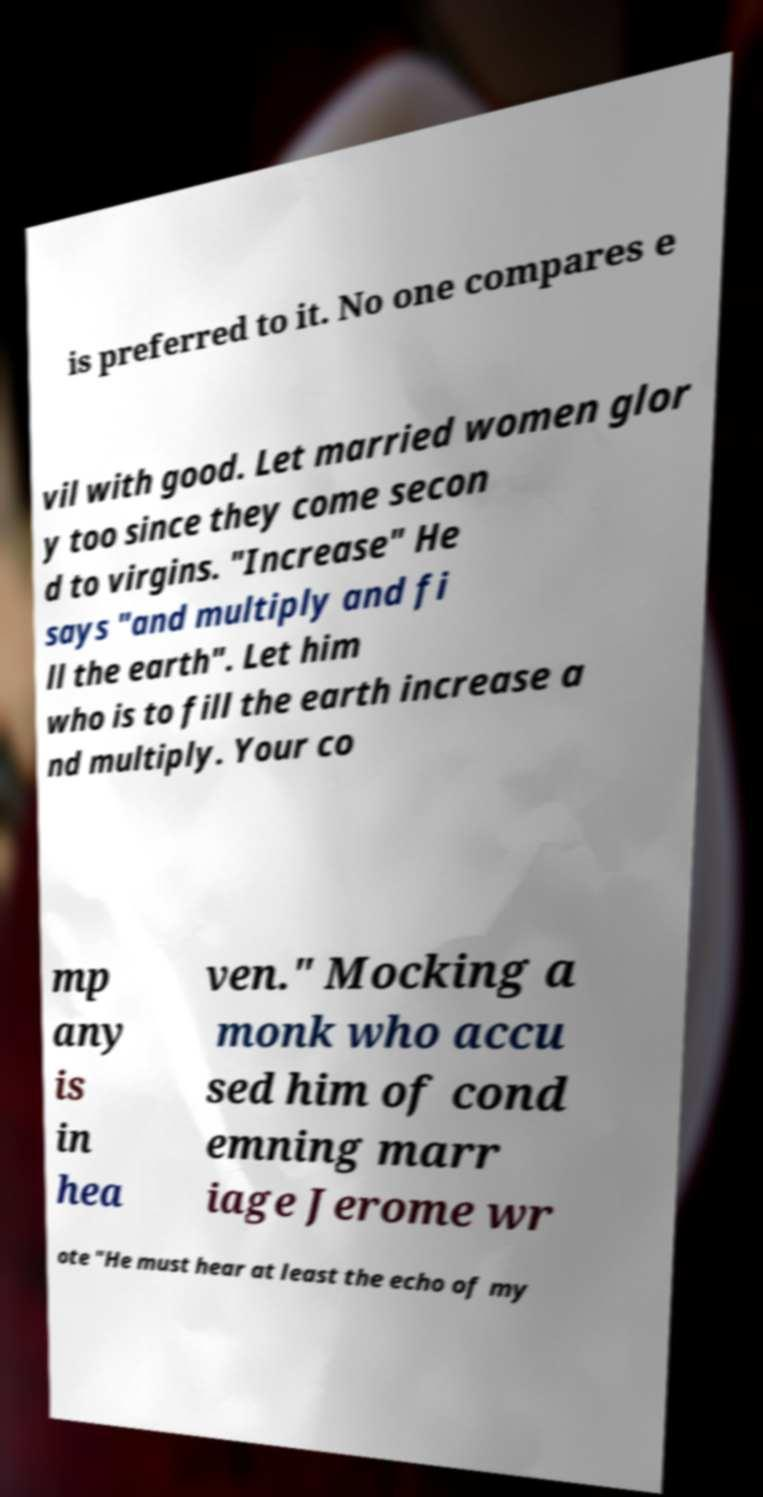Can you accurately transcribe the text from the provided image for me? is preferred to it. No one compares e vil with good. Let married women glor y too since they come secon d to virgins. "Increase" He says "and multiply and fi ll the earth". Let him who is to fill the earth increase a nd multiply. Your co mp any is in hea ven." Mocking a monk who accu sed him of cond emning marr iage Jerome wr ote "He must hear at least the echo of my 